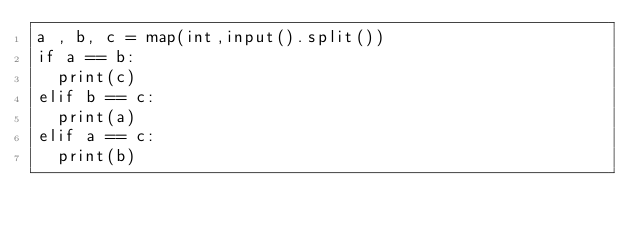<code> <loc_0><loc_0><loc_500><loc_500><_Python_>a , b, c = map(int,input().split())
if a == b:
  print(c)
elif b == c:
  print(a)
elif a == c:
  print(b)
</code> 